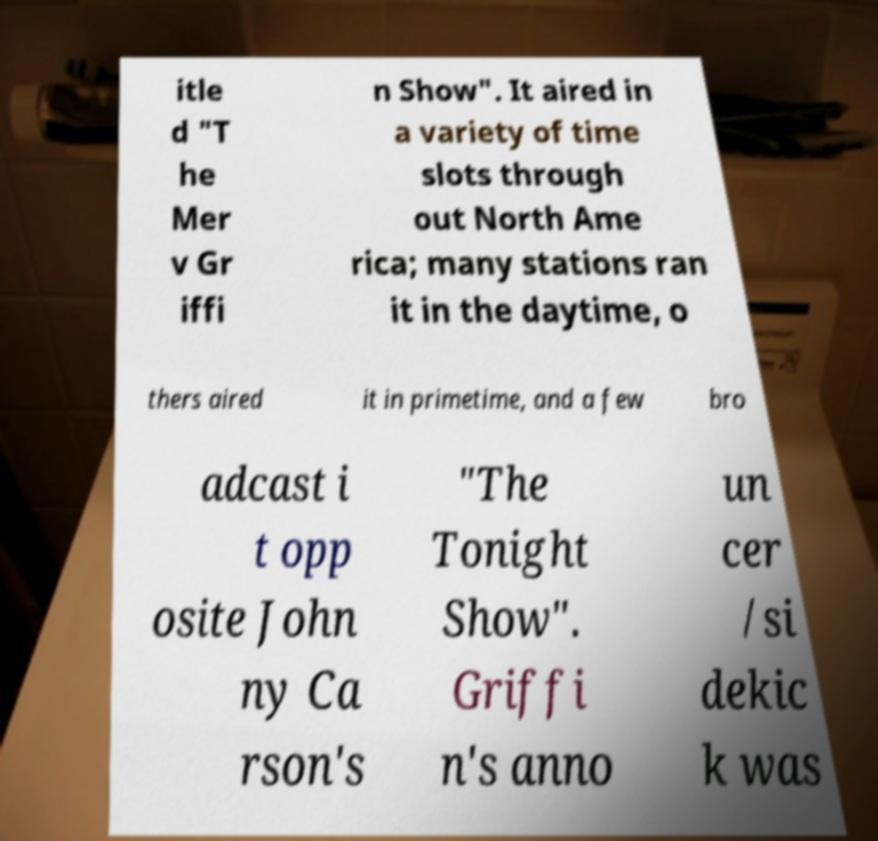I need the written content from this picture converted into text. Can you do that? itle d "T he Mer v Gr iffi n Show". It aired in a variety of time slots through out North Ame rica; many stations ran it in the daytime, o thers aired it in primetime, and a few bro adcast i t opp osite John ny Ca rson's "The Tonight Show". Griffi n's anno un cer /si dekic k was 